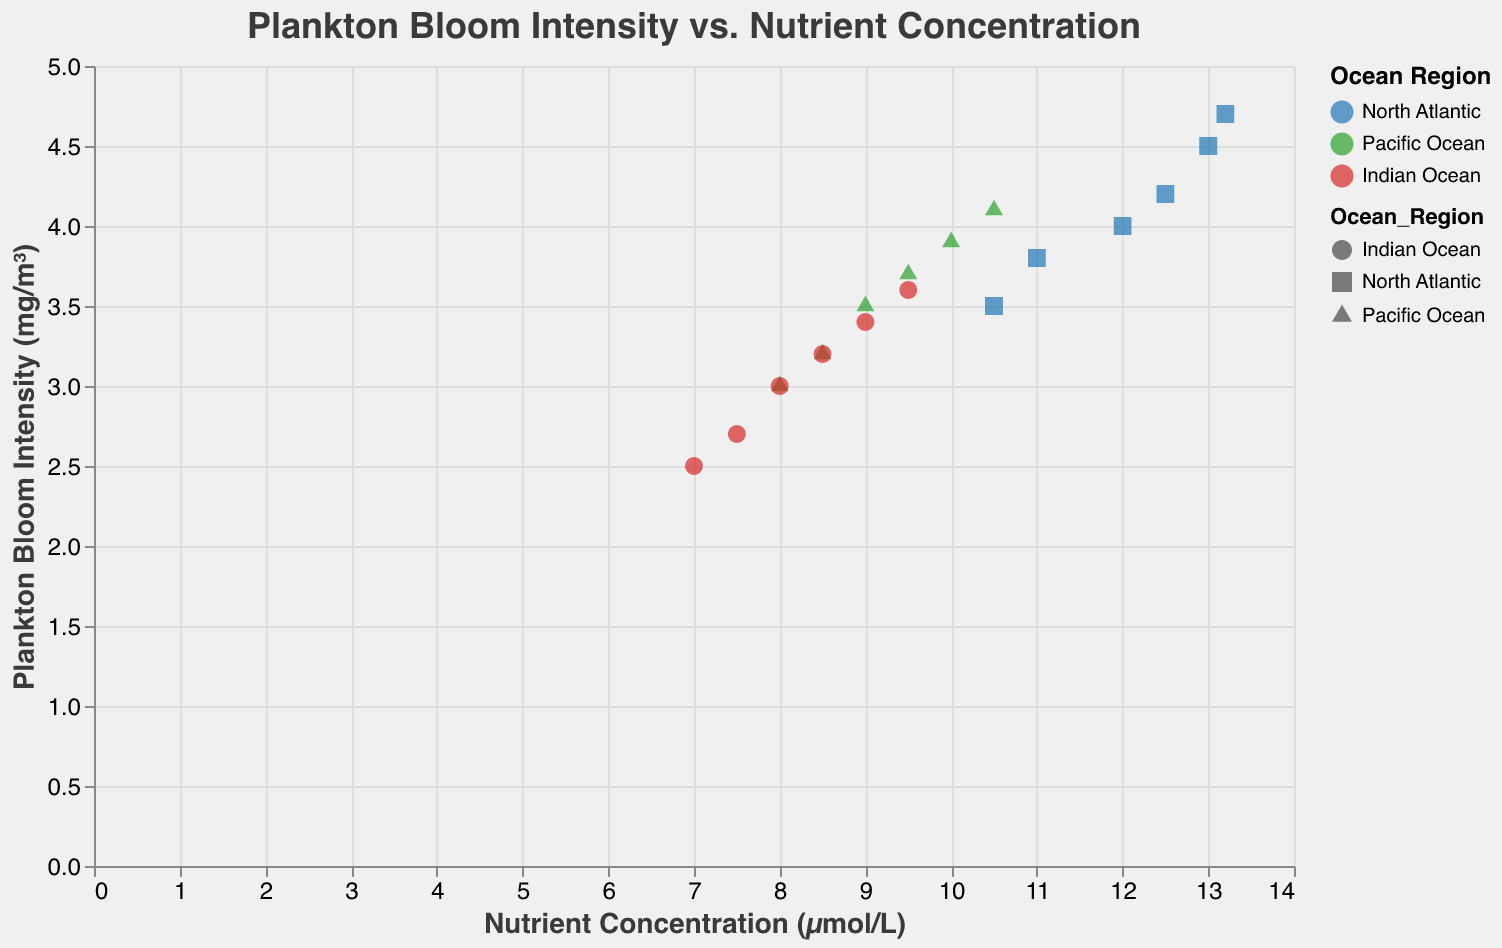What's the title of the plot? The title is placed at the top of the plot and reads "Plankton Bloom Intensity vs. Nutrient Concentration".
Answer: Plankton Bloom Intensity vs. Nutrient Concentration Which ocean region shows the highest plankton bloom intensity at the highest nutrient concentration? The highest plankton bloom intensity at the highest nutrient concentration is shown by a red triangle representing the Indian Ocean, with the values at 9.5 µmol/L and 3.6 mg/m³, located at the upper right of the Indian Ocean data points.
Answer: Indian Ocean What color represents the North Atlantic Ocean? The colors representing different ocean regions are shown in the legend. The hex color code for the North Atlantic Ocean is displayed as blue.
Answer: Blue Which ocean region's trend line has the steepest slope? The steepness of the trend lines can be compared visually. The red trend line representing the Indian Ocean appears to have the steepest slope among the three.
Answer: Indian Ocean What is the range of nutrient concentration in the Pacific Ocean data points? To find the range, look at the data points for the Pacific Ocean represented by green squares. The nutrient concentration ranges from 8.0 to 10.5 µmol/L.
Answer: 8.0 to 10.5 µmol/L Which year shows the highest number of plankton bloom events in the Indian Ocean? The tooltips provide this information. By observing the data points for the Indian Ocean (red triangles), 2005 shows the highest plankton bloom frequency of 14 events/year.
Answer: 2005 Compare the plankton bloom intensity at a nutrient concentration of 10.0 µmol/L for the North Atlantic and Pacific Ocean. Which one is higher and by how much? At 10.0 µmol/L, Pacific Ocean (green square) has a plankton bloom intensity of 3.9 mg/m³ and North Atlantic does not have a data point exactly at 10.0 µmol/L, but slightly higher at 10.5 µmol/L with 3.5 mg/m³. By interpolation, North Atlantic would be lower.
Answer: Pacific Ocean, 0.4 mg/m³ Based on the trend lines, which ocean region shows the most steady increase in plankton bloom intensity with increasing nutrient concentration? By examining the linear trend lines, the Pacific Ocean (green line) appears to exhibit the most steady and less steep increase in plankton bloom intensity.
Answer: Pacific Ocean List all the unique shapes used to represent different ocean regions. The legend indicates the shapes used for different regions: the North Atlantic is a circle, the Pacific Ocean is a square, and the Indian Ocean is a triangle.
Answer: Circle, Square, Triangle Is there a nutrient concentration at which Indian Ocean and Pacific Ocean have similar plankton bloom intensities? By visually inspecting the plot, around 9.0 µmol/L both Indian Ocean (red triangle) and Pacific Ocean (green square) have similar plankton bloom intensities of around 3.5 mg/m³.
Answer: Around 9.0 µmol/L 